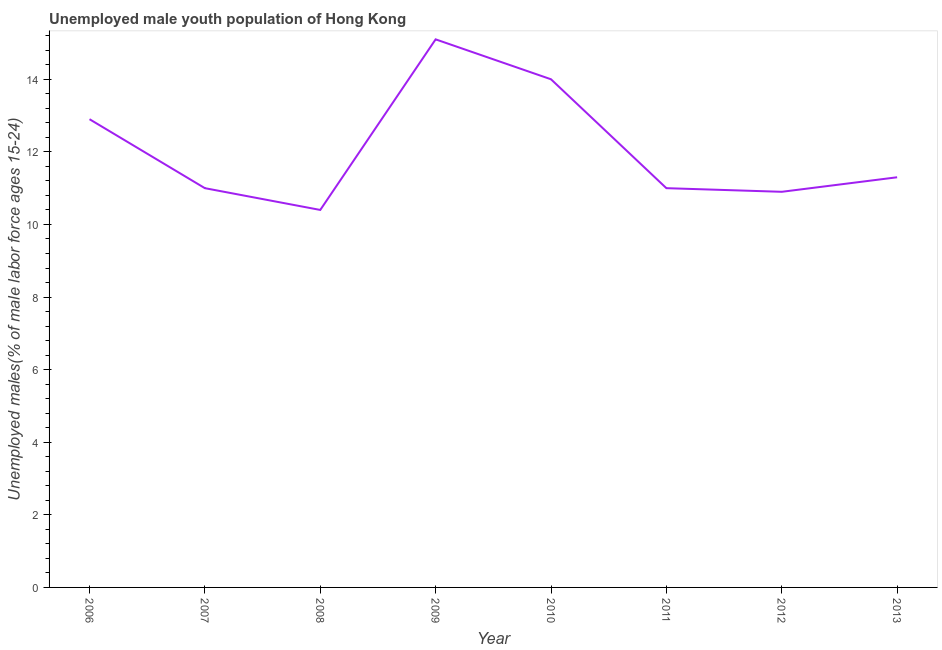What is the unemployed male youth in 2013?
Ensure brevity in your answer.  11.3. Across all years, what is the maximum unemployed male youth?
Provide a succinct answer. 15.1. Across all years, what is the minimum unemployed male youth?
Keep it short and to the point. 10.4. In which year was the unemployed male youth maximum?
Ensure brevity in your answer.  2009. What is the sum of the unemployed male youth?
Offer a very short reply. 96.6. What is the difference between the unemployed male youth in 2007 and 2013?
Provide a short and direct response. -0.3. What is the average unemployed male youth per year?
Ensure brevity in your answer.  12.07. What is the median unemployed male youth?
Keep it short and to the point. 11.15. In how many years, is the unemployed male youth greater than 11.6 %?
Give a very brief answer. 3. What is the ratio of the unemployed male youth in 2008 to that in 2009?
Keep it short and to the point. 0.69. Is the unemployed male youth in 2008 less than that in 2012?
Your answer should be compact. Yes. What is the difference between the highest and the second highest unemployed male youth?
Make the answer very short. 1.1. Is the sum of the unemployed male youth in 2006 and 2013 greater than the maximum unemployed male youth across all years?
Make the answer very short. Yes. What is the difference between the highest and the lowest unemployed male youth?
Offer a terse response. 4.7. How many lines are there?
Provide a short and direct response. 1. What is the difference between two consecutive major ticks on the Y-axis?
Ensure brevity in your answer.  2. Are the values on the major ticks of Y-axis written in scientific E-notation?
Provide a short and direct response. No. Does the graph contain grids?
Offer a very short reply. No. What is the title of the graph?
Provide a succinct answer. Unemployed male youth population of Hong Kong. What is the label or title of the Y-axis?
Keep it short and to the point. Unemployed males(% of male labor force ages 15-24). What is the Unemployed males(% of male labor force ages 15-24) in 2006?
Your answer should be very brief. 12.9. What is the Unemployed males(% of male labor force ages 15-24) in 2008?
Offer a terse response. 10.4. What is the Unemployed males(% of male labor force ages 15-24) in 2009?
Ensure brevity in your answer.  15.1. What is the Unemployed males(% of male labor force ages 15-24) of 2012?
Ensure brevity in your answer.  10.9. What is the Unemployed males(% of male labor force ages 15-24) in 2013?
Your answer should be compact. 11.3. What is the difference between the Unemployed males(% of male labor force ages 15-24) in 2006 and 2008?
Your answer should be compact. 2.5. What is the difference between the Unemployed males(% of male labor force ages 15-24) in 2006 and 2009?
Your response must be concise. -2.2. What is the difference between the Unemployed males(% of male labor force ages 15-24) in 2006 and 2012?
Give a very brief answer. 2. What is the difference between the Unemployed males(% of male labor force ages 15-24) in 2007 and 2009?
Give a very brief answer. -4.1. What is the difference between the Unemployed males(% of male labor force ages 15-24) in 2007 and 2010?
Your answer should be very brief. -3. What is the difference between the Unemployed males(% of male labor force ages 15-24) in 2007 and 2013?
Make the answer very short. -0.3. What is the difference between the Unemployed males(% of male labor force ages 15-24) in 2008 and 2009?
Your answer should be very brief. -4.7. What is the difference between the Unemployed males(% of male labor force ages 15-24) in 2008 and 2011?
Your answer should be compact. -0.6. What is the difference between the Unemployed males(% of male labor force ages 15-24) in 2008 and 2013?
Keep it short and to the point. -0.9. What is the difference between the Unemployed males(% of male labor force ages 15-24) in 2009 and 2010?
Ensure brevity in your answer.  1.1. What is the difference between the Unemployed males(% of male labor force ages 15-24) in 2009 and 2012?
Keep it short and to the point. 4.2. What is the difference between the Unemployed males(% of male labor force ages 15-24) in 2010 and 2013?
Ensure brevity in your answer.  2.7. What is the difference between the Unemployed males(% of male labor force ages 15-24) in 2011 and 2013?
Provide a short and direct response. -0.3. What is the ratio of the Unemployed males(% of male labor force ages 15-24) in 2006 to that in 2007?
Keep it short and to the point. 1.17. What is the ratio of the Unemployed males(% of male labor force ages 15-24) in 2006 to that in 2008?
Provide a succinct answer. 1.24. What is the ratio of the Unemployed males(% of male labor force ages 15-24) in 2006 to that in 2009?
Make the answer very short. 0.85. What is the ratio of the Unemployed males(% of male labor force ages 15-24) in 2006 to that in 2010?
Your response must be concise. 0.92. What is the ratio of the Unemployed males(% of male labor force ages 15-24) in 2006 to that in 2011?
Your response must be concise. 1.17. What is the ratio of the Unemployed males(% of male labor force ages 15-24) in 2006 to that in 2012?
Your response must be concise. 1.18. What is the ratio of the Unemployed males(% of male labor force ages 15-24) in 2006 to that in 2013?
Offer a terse response. 1.14. What is the ratio of the Unemployed males(% of male labor force ages 15-24) in 2007 to that in 2008?
Ensure brevity in your answer.  1.06. What is the ratio of the Unemployed males(% of male labor force ages 15-24) in 2007 to that in 2009?
Provide a short and direct response. 0.73. What is the ratio of the Unemployed males(% of male labor force ages 15-24) in 2007 to that in 2010?
Offer a terse response. 0.79. What is the ratio of the Unemployed males(% of male labor force ages 15-24) in 2007 to that in 2012?
Your answer should be compact. 1.01. What is the ratio of the Unemployed males(% of male labor force ages 15-24) in 2008 to that in 2009?
Your answer should be compact. 0.69. What is the ratio of the Unemployed males(% of male labor force ages 15-24) in 2008 to that in 2010?
Your response must be concise. 0.74. What is the ratio of the Unemployed males(% of male labor force ages 15-24) in 2008 to that in 2011?
Offer a terse response. 0.94. What is the ratio of the Unemployed males(% of male labor force ages 15-24) in 2008 to that in 2012?
Offer a terse response. 0.95. What is the ratio of the Unemployed males(% of male labor force ages 15-24) in 2008 to that in 2013?
Your answer should be compact. 0.92. What is the ratio of the Unemployed males(% of male labor force ages 15-24) in 2009 to that in 2010?
Offer a terse response. 1.08. What is the ratio of the Unemployed males(% of male labor force ages 15-24) in 2009 to that in 2011?
Offer a terse response. 1.37. What is the ratio of the Unemployed males(% of male labor force ages 15-24) in 2009 to that in 2012?
Offer a very short reply. 1.39. What is the ratio of the Unemployed males(% of male labor force ages 15-24) in 2009 to that in 2013?
Your answer should be very brief. 1.34. What is the ratio of the Unemployed males(% of male labor force ages 15-24) in 2010 to that in 2011?
Offer a terse response. 1.27. What is the ratio of the Unemployed males(% of male labor force ages 15-24) in 2010 to that in 2012?
Your answer should be compact. 1.28. What is the ratio of the Unemployed males(% of male labor force ages 15-24) in 2010 to that in 2013?
Provide a succinct answer. 1.24. What is the ratio of the Unemployed males(% of male labor force ages 15-24) in 2011 to that in 2012?
Provide a succinct answer. 1.01. What is the ratio of the Unemployed males(% of male labor force ages 15-24) in 2011 to that in 2013?
Ensure brevity in your answer.  0.97. 